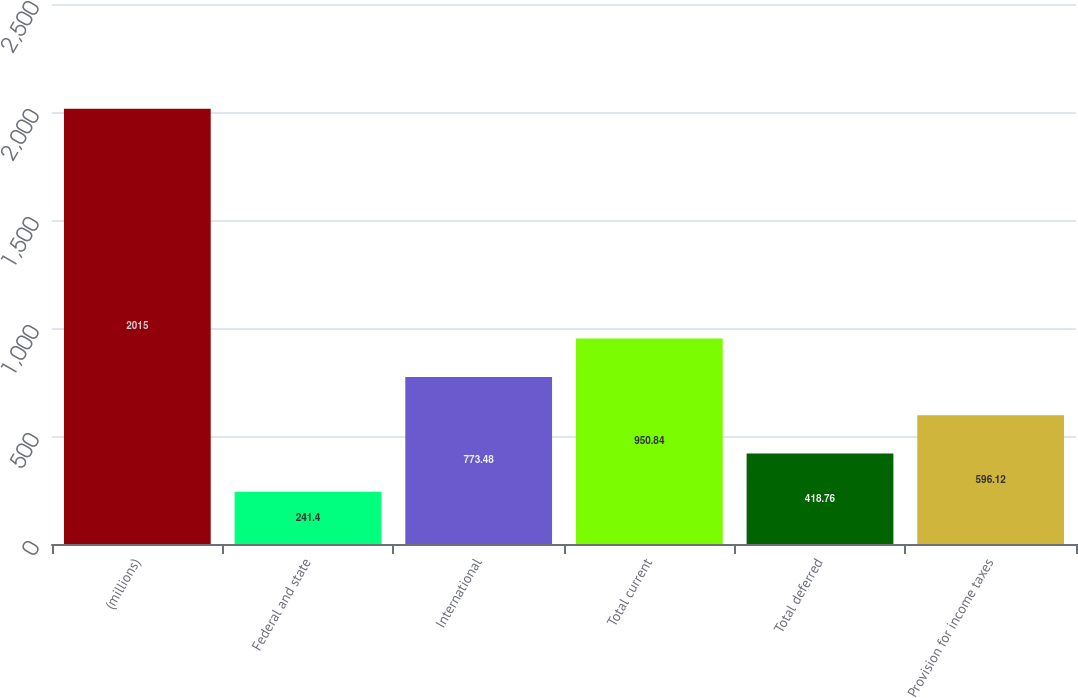<chart> <loc_0><loc_0><loc_500><loc_500><bar_chart><fcel>(millions)<fcel>Federal and state<fcel>International<fcel>Total current<fcel>Total deferred<fcel>Provision for income taxes<nl><fcel>2015<fcel>241.4<fcel>773.48<fcel>950.84<fcel>418.76<fcel>596.12<nl></chart> 